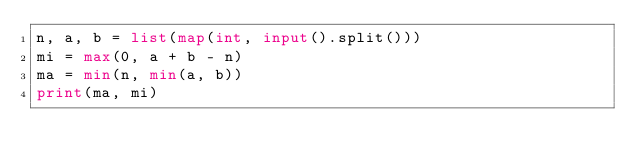Convert code to text. <code><loc_0><loc_0><loc_500><loc_500><_Python_>n, a, b = list(map(int, input().split()))
mi = max(0, a + b - n)
ma = min(n, min(a, b))
print(ma, mi)</code> 